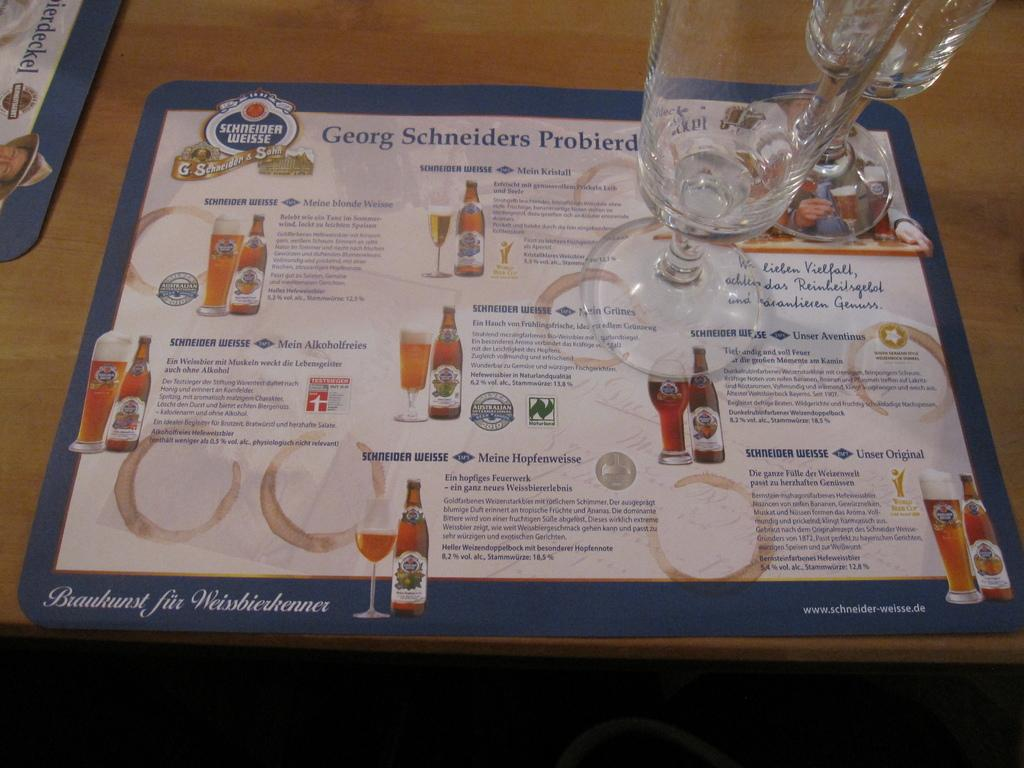<image>
Describe the image concisely. A place mat menu of different types of ales by Schneider Weisse. 